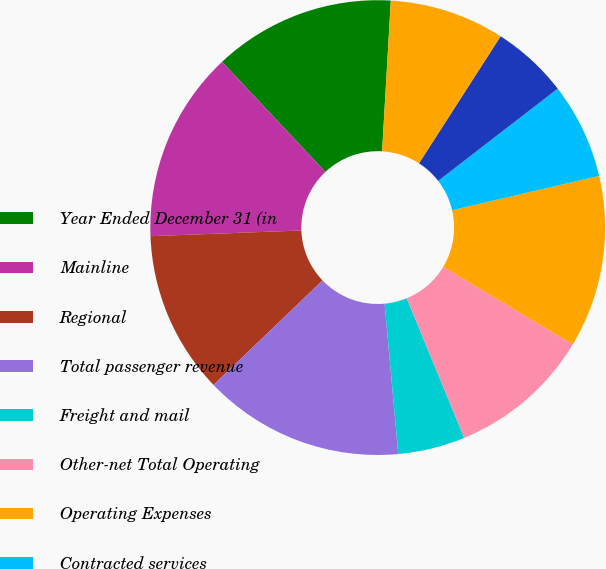Convert chart. <chart><loc_0><loc_0><loc_500><loc_500><pie_chart><fcel>Year Ended December 31 (in<fcel>Mainline<fcel>Regional<fcel>Total passenger revenue<fcel>Freight and mail<fcel>Other-net Total Operating<fcel>Operating Expenses<fcel>Contracted services<fcel>Selling expenses<fcel>Depreciation and amortization<nl><fcel>12.92%<fcel>13.6%<fcel>11.56%<fcel>14.28%<fcel>4.77%<fcel>10.2%<fcel>12.24%<fcel>6.81%<fcel>5.45%<fcel>8.17%<nl></chart> 